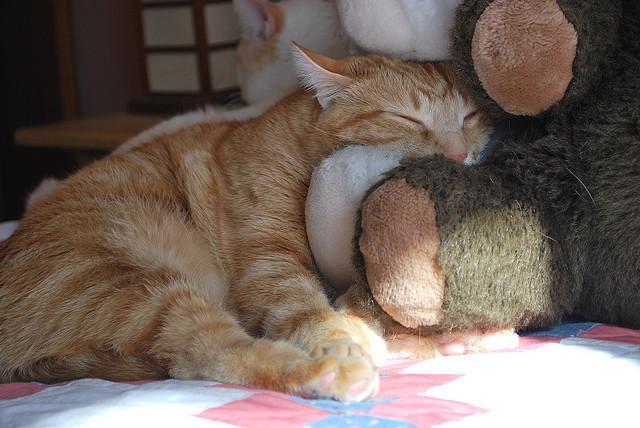How many zebras are in the picture?
Give a very brief answer. 0. 